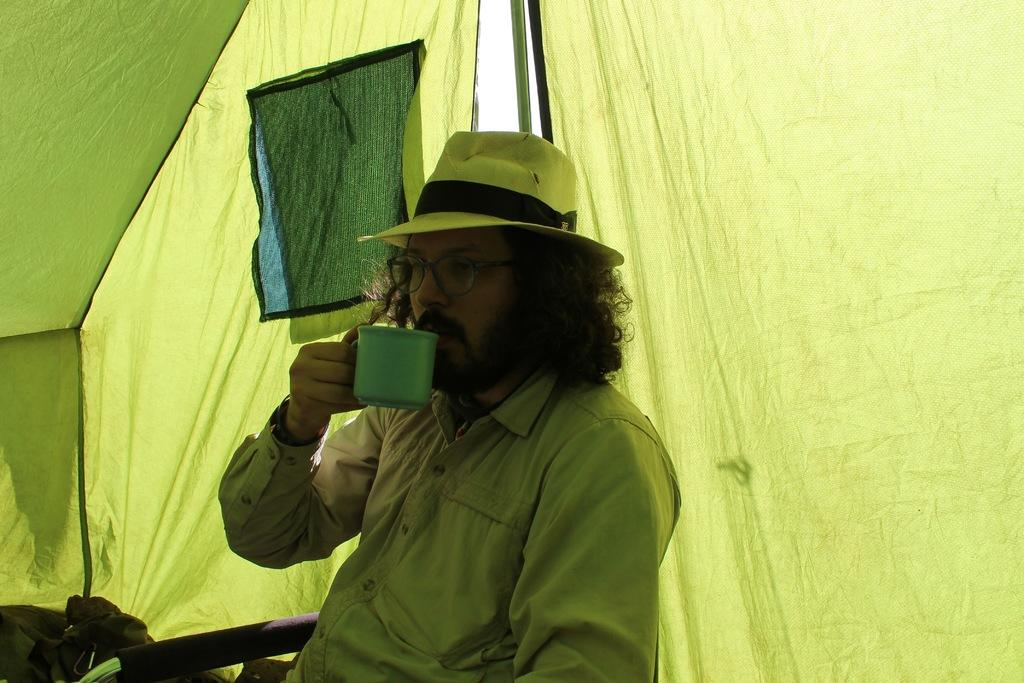Who is present in the image? There is a man in the image. What is the man doing in the image? The man is sitting on a chair in the image. What is the man holding in his hand? The man is holding a cup in his hand. What can be seen in the background of the image? There is a tent in the background of the image. What type of dolls can be seen playing in the wind in the image? There are no dolls or wind present in the image; it features a man sitting on a chair holding a cup, with a tent in the background. 